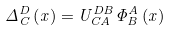<formula> <loc_0><loc_0><loc_500><loc_500>\Delta _ { C } ^ { D } \left ( x \right ) = U _ { C A } ^ { D B } \Phi _ { B } ^ { A } \left ( x \right )</formula> 